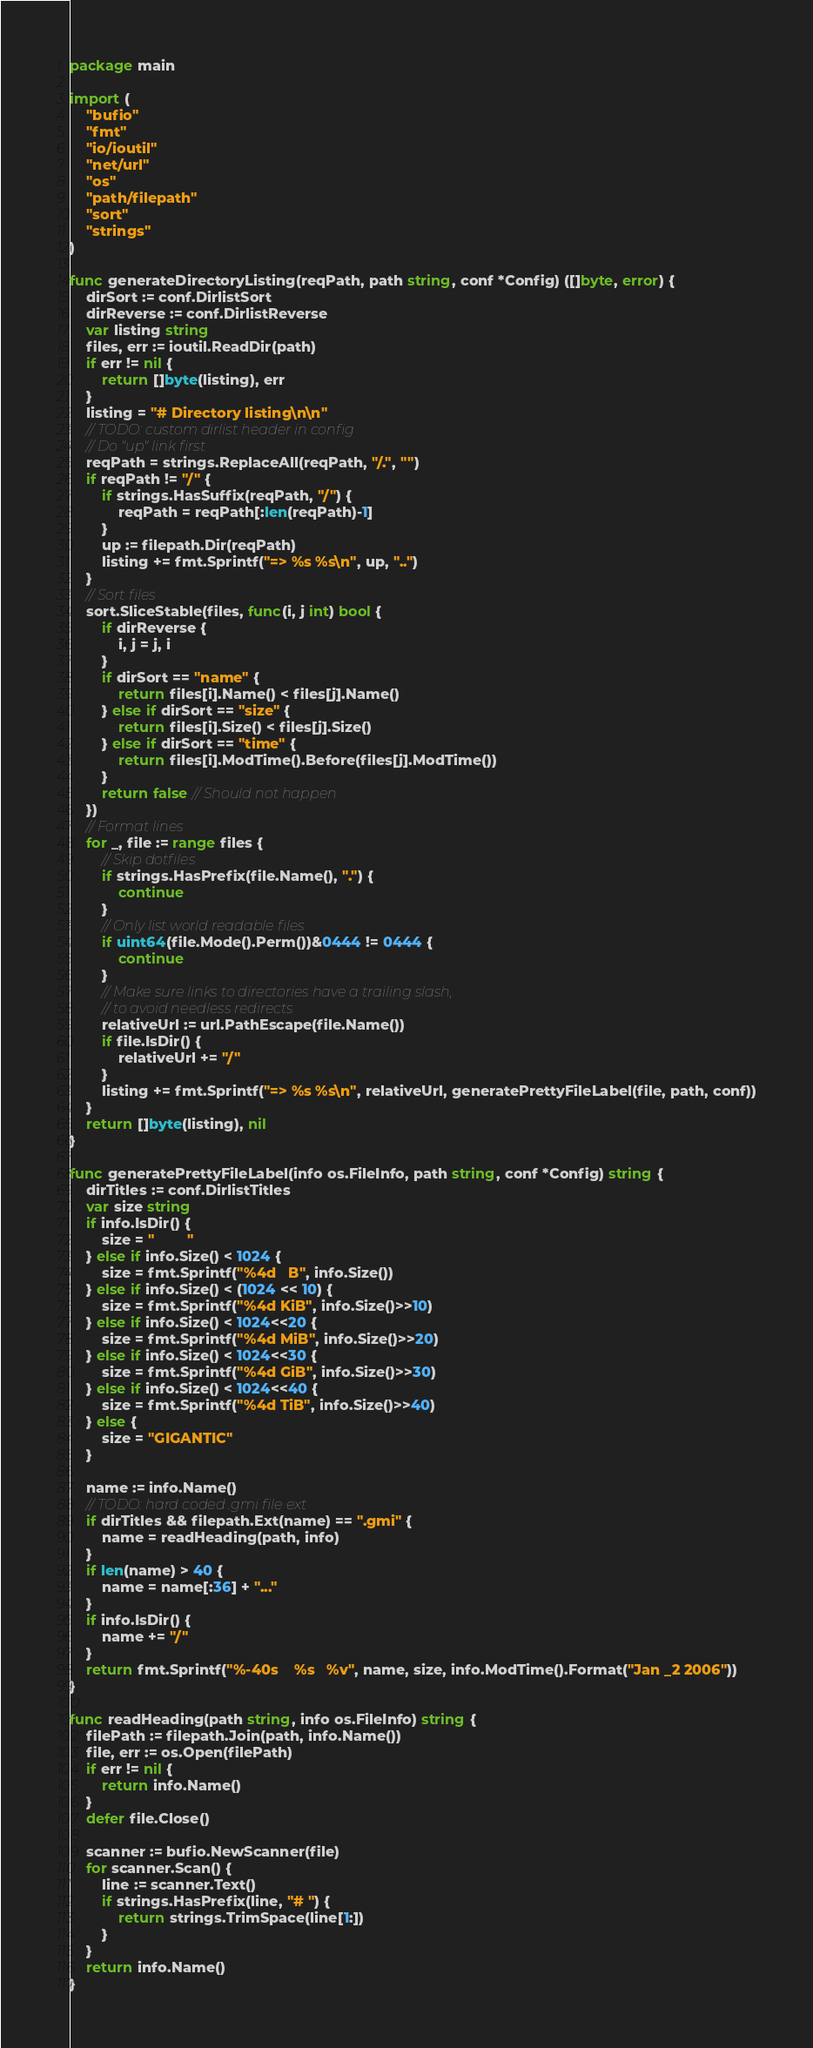<code> <loc_0><loc_0><loc_500><loc_500><_Go_>package main

import (
	"bufio"
	"fmt"
	"io/ioutil"
	"net/url"
	"os"
	"path/filepath"
	"sort"
	"strings"
)

func generateDirectoryListing(reqPath, path string, conf *Config) ([]byte, error) {
	dirSort := conf.DirlistSort
	dirReverse := conf.DirlistReverse
	var listing string
	files, err := ioutil.ReadDir(path)
	if err != nil {
		return []byte(listing), err
	}
	listing = "# Directory listing\n\n"
	// TODO: custom dirlist header in config
	// Do "up" link first
	reqPath = strings.ReplaceAll(reqPath, "/.", "")
	if reqPath != "/" {
		if strings.HasSuffix(reqPath, "/") {
			reqPath = reqPath[:len(reqPath)-1]
		}
		up := filepath.Dir(reqPath)
		listing += fmt.Sprintf("=> %s %s\n", up, "..")
	}
	// Sort files
	sort.SliceStable(files, func(i, j int) bool {
		if dirReverse {
			i, j = j, i
		}
		if dirSort == "name" {
			return files[i].Name() < files[j].Name()
		} else if dirSort == "size" {
			return files[i].Size() < files[j].Size()
		} else if dirSort == "time" {
			return files[i].ModTime().Before(files[j].ModTime())
		}
		return false // Should not happen
	})
	// Format lines
	for _, file := range files {
		// Skip dotfiles
		if strings.HasPrefix(file.Name(), ".") {
			continue
		}
		// Only list world readable files
		if uint64(file.Mode().Perm())&0444 != 0444 {
			continue
		}
		// Make sure links to directories have a trailing slash,
		// to avoid needless redirects
		relativeUrl := url.PathEscape(file.Name())
		if file.IsDir() {
			relativeUrl += "/"
		}
		listing += fmt.Sprintf("=> %s %s\n", relativeUrl, generatePrettyFileLabel(file, path, conf))
	}
	return []byte(listing), nil
}

func generatePrettyFileLabel(info os.FileInfo, path string, conf *Config) string {
	dirTitles := conf.DirlistTitles
	var size string
	if info.IsDir() {
		size = "        "
	} else if info.Size() < 1024 {
		size = fmt.Sprintf("%4d   B", info.Size())
	} else if info.Size() < (1024 << 10) {
		size = fmt.Sprintf("%4d KiB", info.Size()>>10)
	} else if info.Size() < 1024<<20 {
		size = fmt.Sprintf("%4d MiB", info.Size()>>20)
	} else if info.Size() < 1024<<30 {
		size = fmt.Sprintf("%4d GiB", info.Size()>>30)
	} else if info.Size() < 1024<<40 {
		size = fmt.Sprintf("%4d TiB", info.Size()>>40)
	} else {
		size = "GIGANTIC"
	}

	name := info.Name()
	// TODO: hard coded .gmi file ext
	if dirTitles && filepath.Ext(name) == ".gmi" {
		name = readHeading(path, info)
	}
	if len(name) > 40 {
		name = name[:36] + "..."
	}
	if info.IsDir() {
		name += "/"
	}
	return fmt.Sprintf("%-40s    %s   %v", name, size, info.ModTime().Format("Jan _2 2006"))
}

func readHeading(path string, info os.FileInfo) string {
	filePath := filepath.Join(path, info.Name())
	file, err := os.Open(filePath)
	if err != nil {
		return info.Name()
	}
	defer file.Close()

	scanner := bufio.NewScanner(file)
	for scanner.Scan() {
		line := scanner.Text()
		if strings.HasPrefix(line, "# ") {
			return strings.TrimSpace(line[1:])
		}
	}
	return info.Name()
}
</code> 